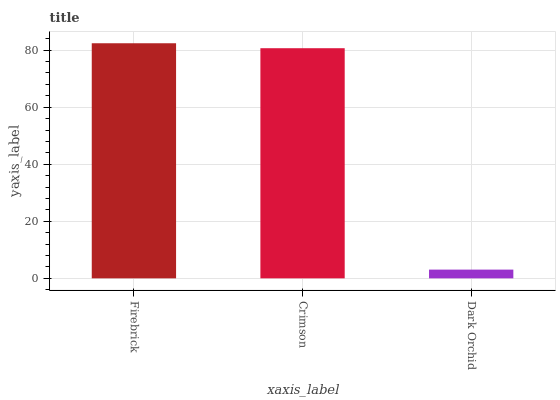Is Dark Orchid the minimum?
Answer yes or no. Yes. Is Firebrick the maximum?
Answer yes or no. Yes. Is Crimson the minimum?
Answer yes or no. No. Is Crimson the maximum?
Answer yes or no. No. Is Firebrick greater than Crimson?
Answer yes or no. Yes. Is Crimson less than Firebrick?
Answer yes or no. Yes. Is Crimson greater than Firebrick?
Answer yes or no. No. Is Firebrick less than Crimson?
Answer yes or no. No. Is Crimson the high median?
Answer yes or no. Yes. Is Crimson the low median?
Answer yes or no. Yes. Is Dark Orchid the high median?
Answer yes or no. No. Is Firebrick the low median?
Answer yes or no. No. 